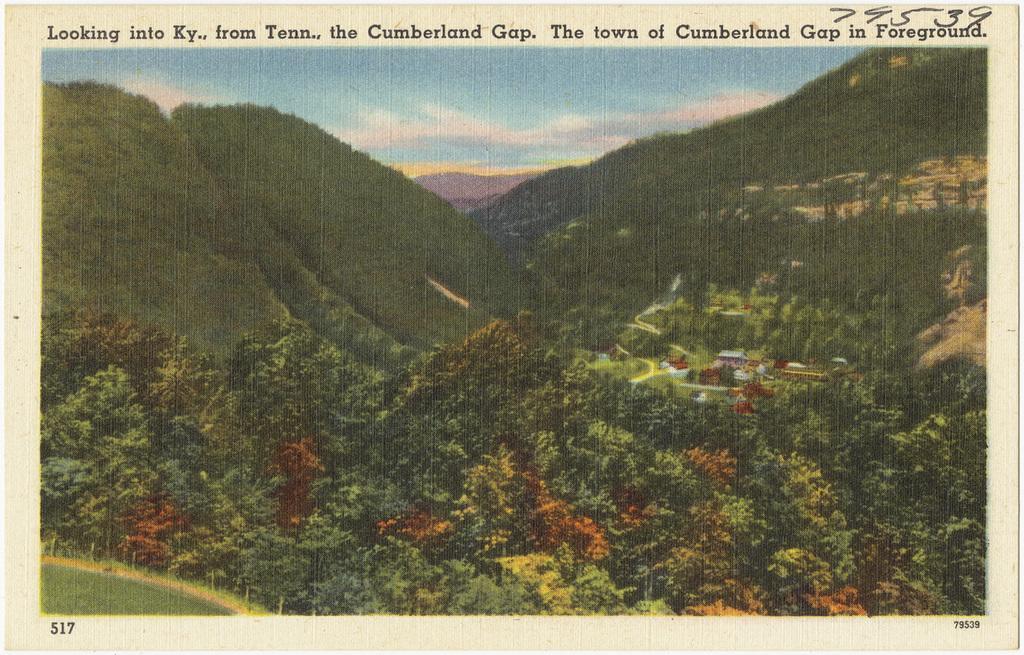In one or two sentences, can you explain what this image depicts? In the image I can see the poster. In the image I can see groups of trees. There are clouds in the sky. 